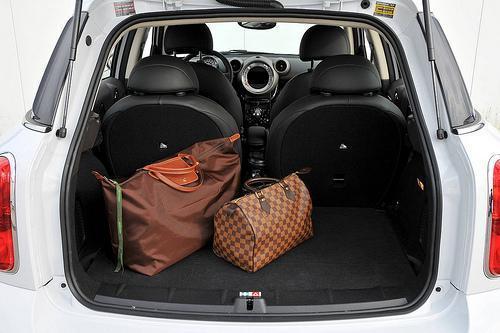How many bags are there?
Give a very brief answer. 2. How many cars are there?
Give a very brief answer. 1. How many seats can you see?
Give a very brief answer. 4. 